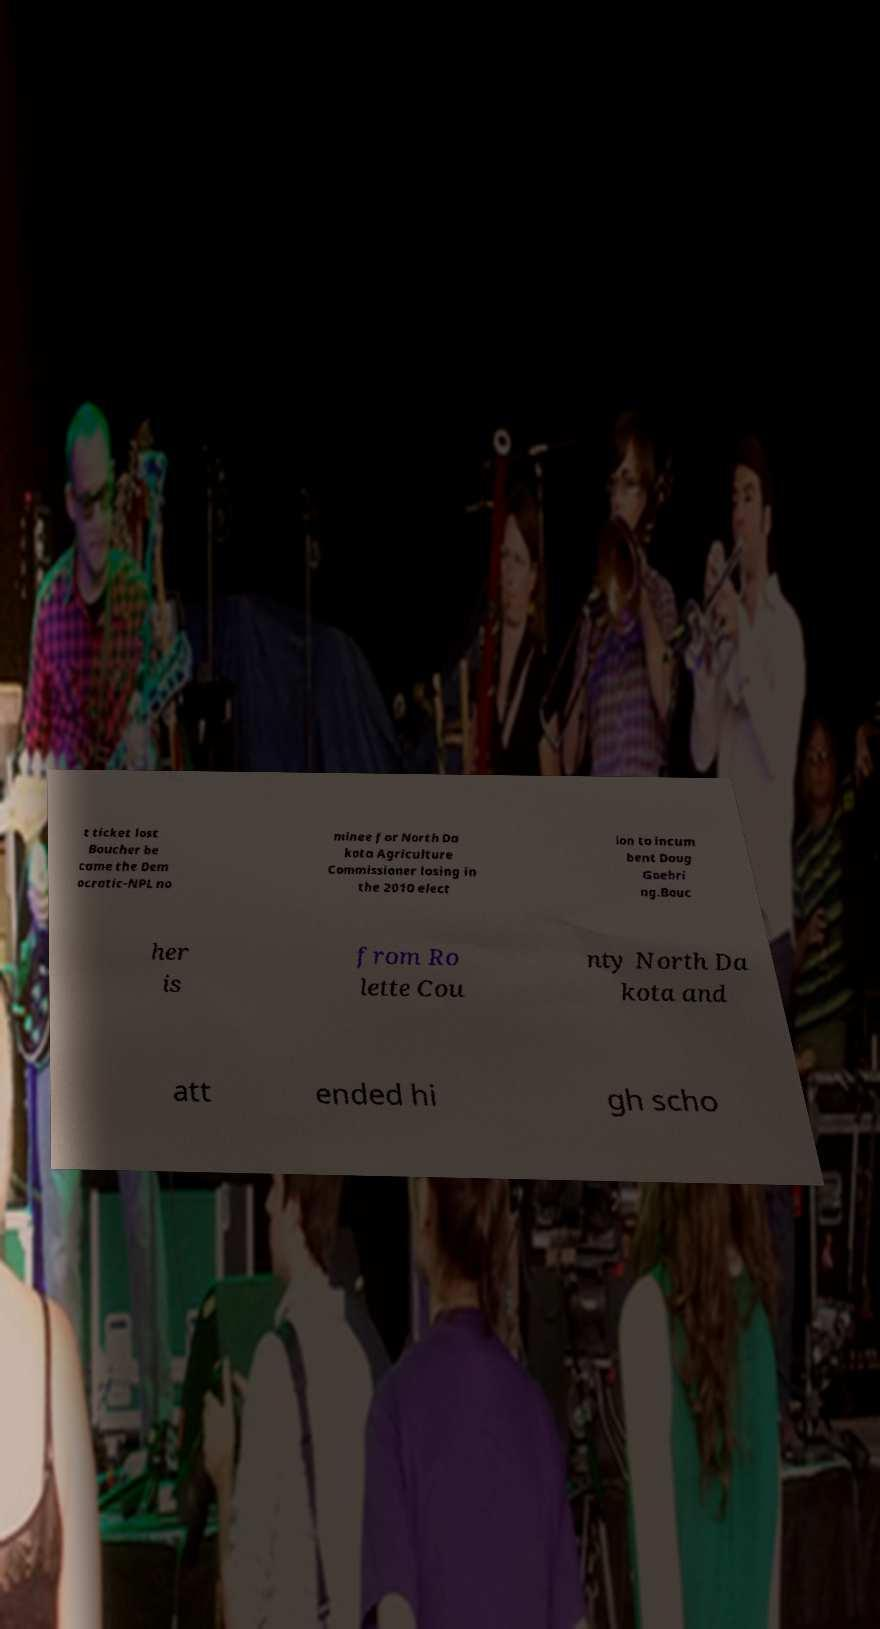Can you read and provide the text displayed in the image?This photo seems to have some interesting text. Can you extract and type it out for me? t ticket lost Boucher be came the Dem ocratic-NPL no minee for North Da kota Agriculture Commissioner losing in the 2010 elect ion to incum bent Doug Goehri ng.Bouc her is from Ro lette Cou nty North Da kota and att ended hi gh scho 